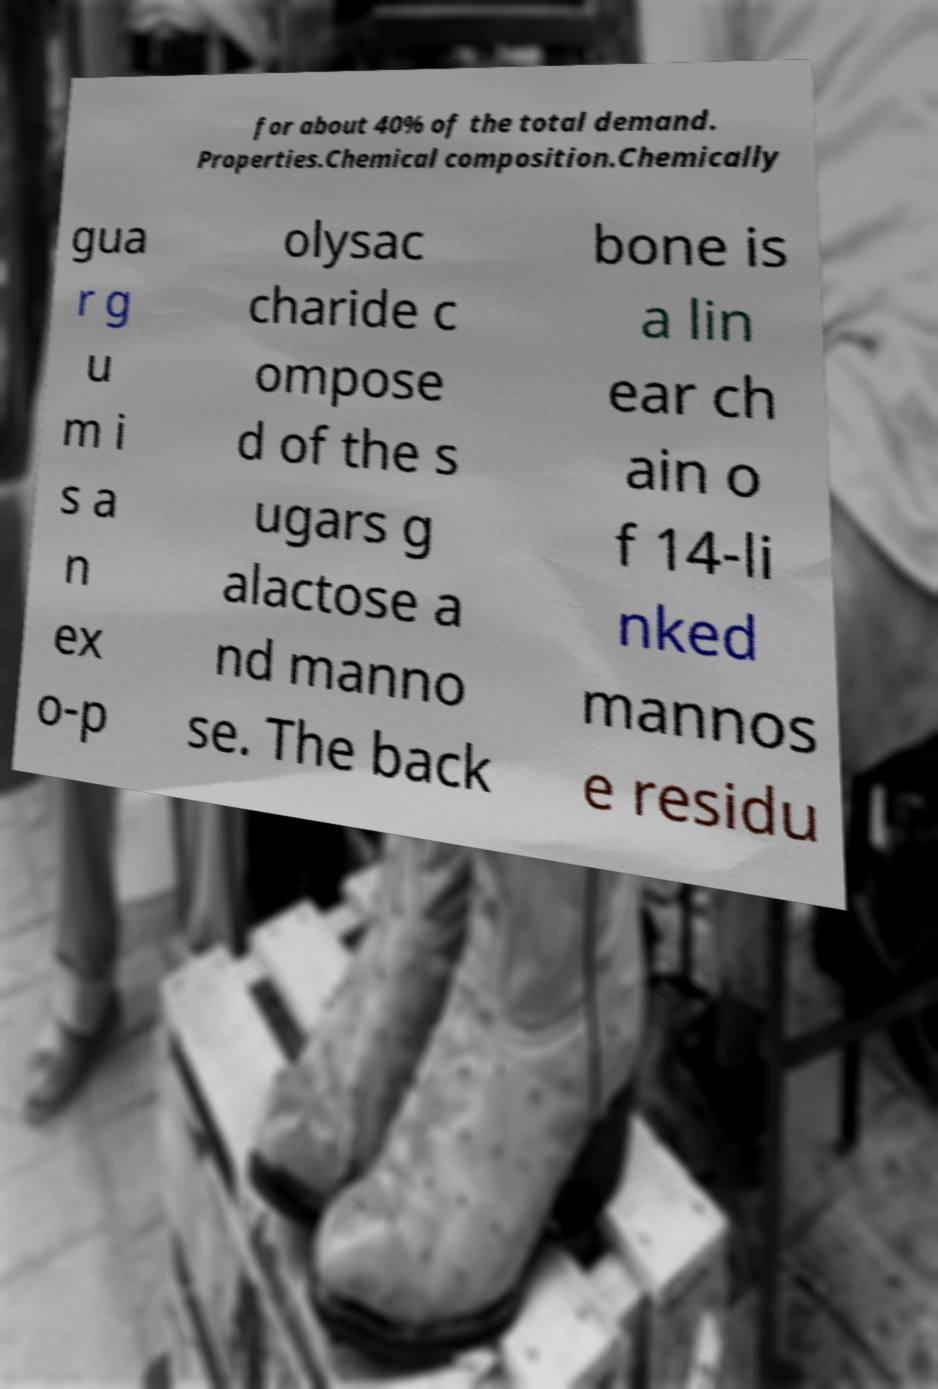Please identify and transcribe the text found in this image. for about 40% of the total demand. Properties.Chemical composition.Chemically gua r g u m i s a n ex o-p olysac charide c ompose d of the s ugars g alactose a nd manno se. The back bone is a lin ear ch ain o f 14-li nked mannos e residu 